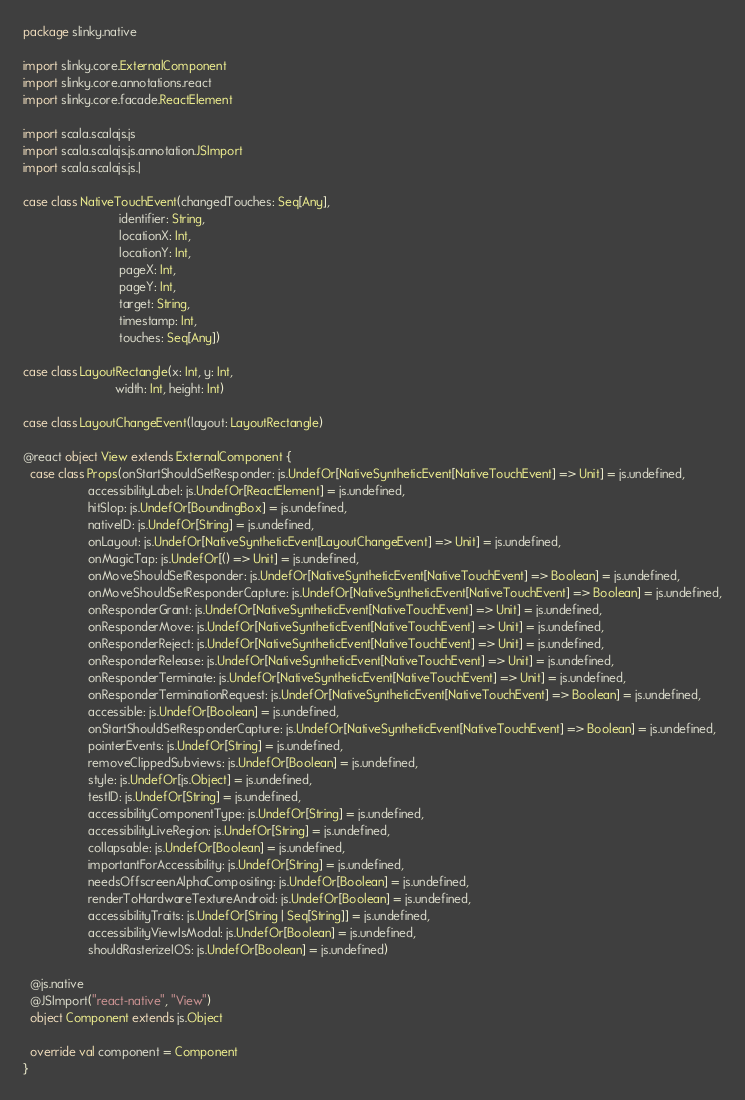<code> <loc_0><loc_0><loc_500><loc_500><_Scala_>package slinky.native

import slinky.core.ExternalComponent
import slinky.core.annotations.react
import slinky.core.facade.ReactElement

import scala.scalajs.js
import scala.scalajs.js.annotation.JSImport
import scala.scalajs.js.|

case class NativeTouchEvent(changedTouches: Seq[Any],
                            identifier: String,
                            locationX: Int,
                            locationY: Int,
                            pageX: Int,
                            pageY: Int,
                            target: String,
                            timestamp: Int,
                            touches: Seq[Any])

case class LayoutRectangle(x: Int, y: Int,
                           width: Int, height: Int)

case class LayoutChangeEvent(layout: LayoutRectangle)

@react object View extends ExternalComponent {
  case class Props(onStartShouldSetResponder: js.UndefOr[NativeSyntheticEvent[NativeTouchEvent] => Unit] = js.undefined,
                   accessibilityLabel: js.UndefOr[ReactElement] = js.undefined,
                   hitSlop: js.UndefOr[BoundingBox] = js.undefined,
                   nativeID: js.UndefOr[String] = js.undefined,
                   onLayout: js.UndefOr[NativeSyntheticEvent[LayoutChangeEvent] => Unit] = js.undefined,
                   onMagicTap: js.UndefOr[() => Unit] = js.undefined,
                   onMoveShouldSetResponder: js.UndefOr[NativeSyntheticEvent[NativeTouchEvent] => Boolean] = js.undefined,
                   onMoveShouldSetResponderCapture: js.UndefOr[NativeSyntheticEvent[NativeTouchEvent] => Boolean] = js.undefined,
                   onResponderGrant: js.UndefOr[NativeSyntheticEvent[NativeTouchEvent] => Unit] = js.undefined,
                   onResponderMove: js.UndefOr[NativeSyntheticEvent[NativeTouchEvent] => Unit] = js.undefined,
                   onResponderReject: js.UndefOr[NativeSyntheticEvent[NativeTouchEvent] => Unit] = js.undefined,
                   onResponderRelease: js.UndefOr[NativeSyntheticEvent[NativeTouchEvent] => Unit] = js.undefined,
                   onResponderTerminate: js.UndefOr[NativeSyntheticEvent[NativeTouchEvent] => Unit] = js.undefined,
                   onResponderTerminationRequest: js.UndefOr[NativeSyntheticEvent[NativeTouchEvent] => Boolean] = js.undefined,
                   accessible: js.UndefOr[Boolean] = js.undefined,
                   onStartShouldSetResponderCapture: js.UndefOr[NativeSyntheticEvent[NativeTouchEvent] => Boolean] = js.undefined,
                   pointerEvents: js.UndefOr[String] = js.undefined,
                   removeClippedSubviews: js.UndefOr[Boolean] = js.undefined,
                   style: js.UndefOr[js.Object] = js.undefined,
                   testID: js.UndefOr[String] = js.undefined,
                   accessibilityComponentType: js.UndefOr[String] = js.undefined,
                   accessibilityLiveRegion: js.UndefOr[String] = js.undefined,
                   collapsable: js.UndefOr[Boolean] = js.undefined,
                   importantForAccessibility: js.UndefOr[String] = js.undefined,
                   needsOffscreenAlphaCompositing: js.UndefOr[Boolean] = js.undefined,
                   renderToHardwareTextureAndroid: js.UndefOr[Boolean] = js.undefined,
                   accessibilityTraits: js.UndefOr[String | Seq[String]] = js.undefined,
                   accessibilityViewIsModal: js.UndefOr[Boolean] = js.undefined,
                   shouldRasterizeIOS: js.UndefOr[Boolean] = js.undefined)

  @js.native
  @JSImport("react-native", "View")
  object Component extends js.Object

  override val component = Component
}
</code> 